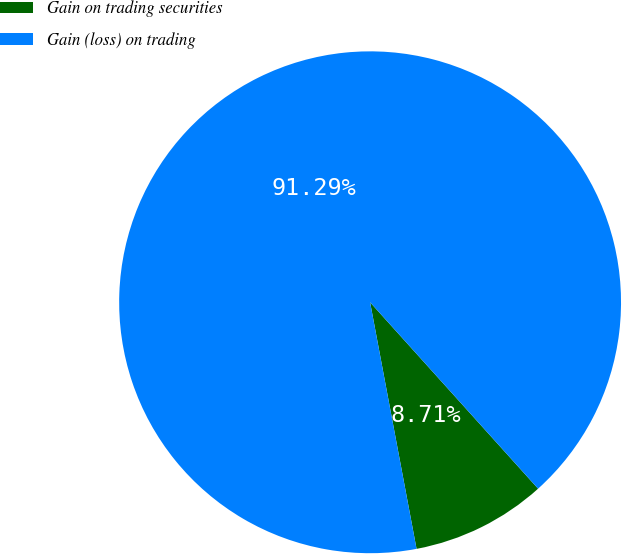Convert chart to OTSL. <chart><loc_0><loc_0><loc_500><loc_500><pie_chart><fcel>Gain on trading securities<fcel>Gain (loss) on trading<nl><fcel>8.71%<fcel>91.29%<nl></chart> 